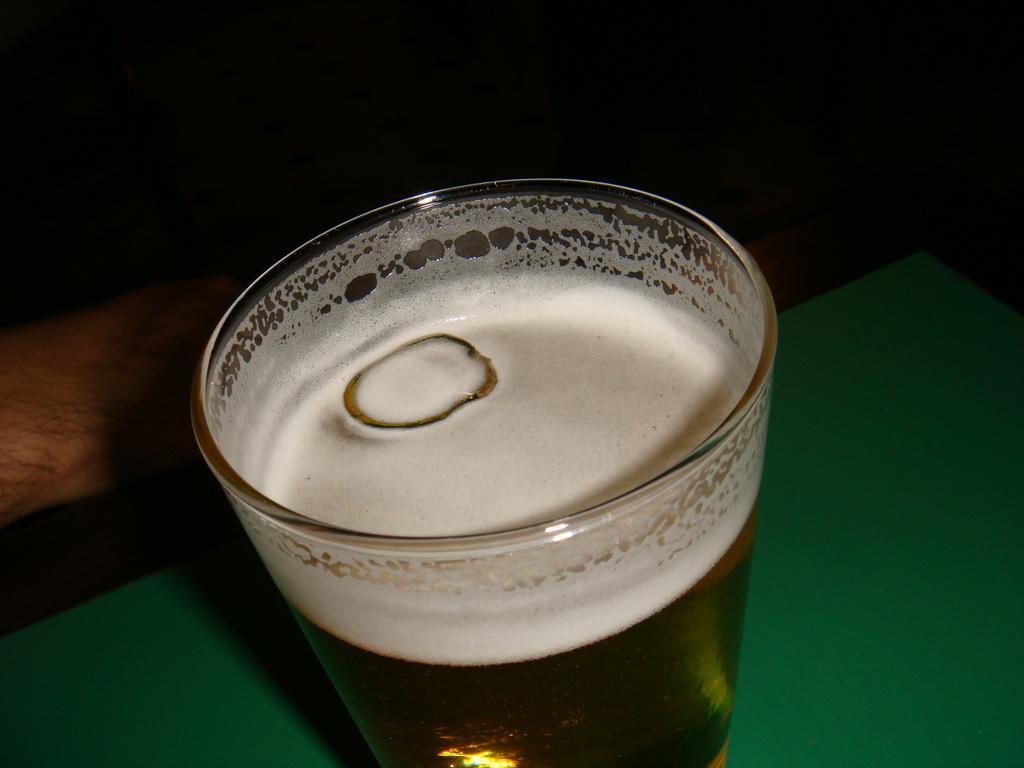Could you give a brief overview of what you see in this image? As we can see in the image, there is a glass on table. On the left there is a human hand. 